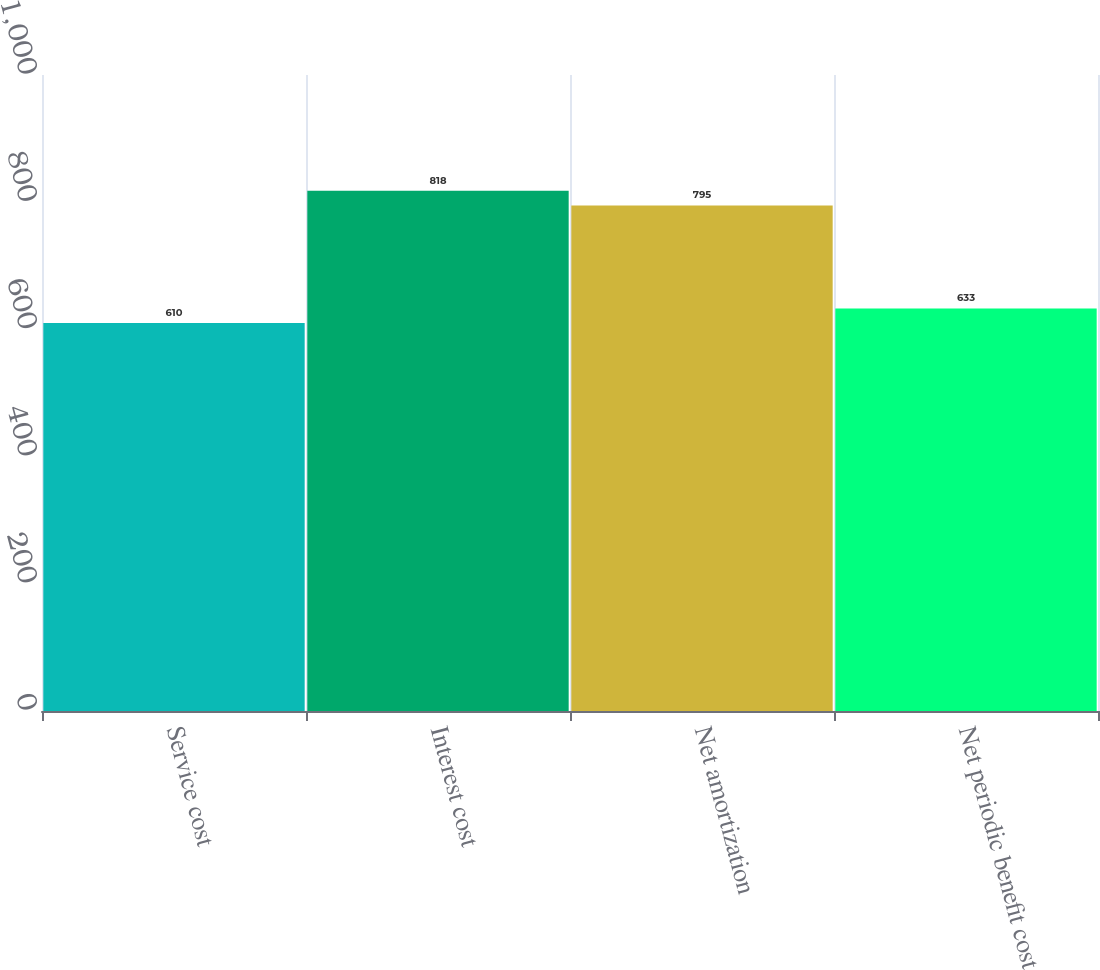<chart> <loc_0><loc_0><loc_500><loc_500><bar_chart><fcel>Service cost<fcel>Interest cost<fcel>Net amortization<fcel>Net periodic benefit cost<nl><fcel>610<fcel>818<fcel>795<fcel>633<nl></chart> 